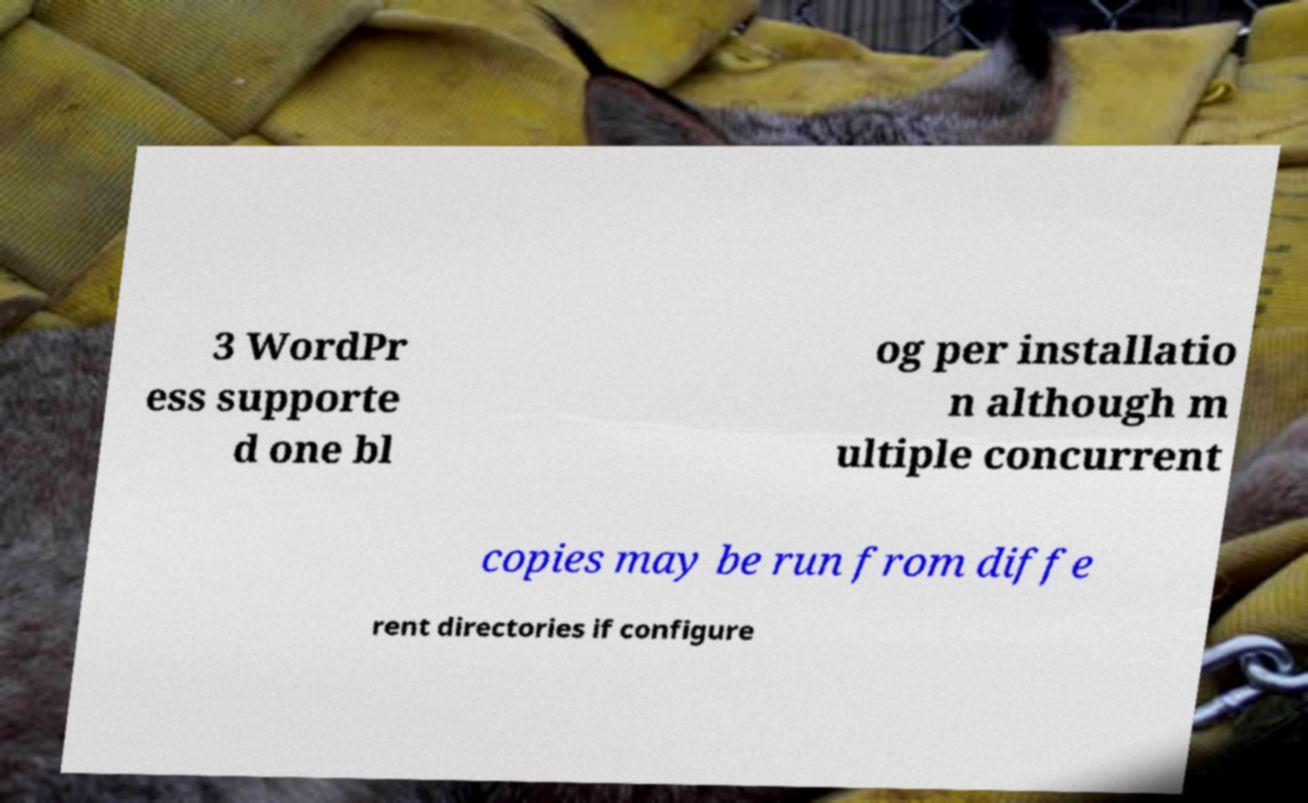For documentation purposes, I need the text within this image transcribed. Could you provide that? 3 WordPr ess supporte d one bl og per installatio n although m ultiple concurrent copies may be run from diffe rent directories if configure 